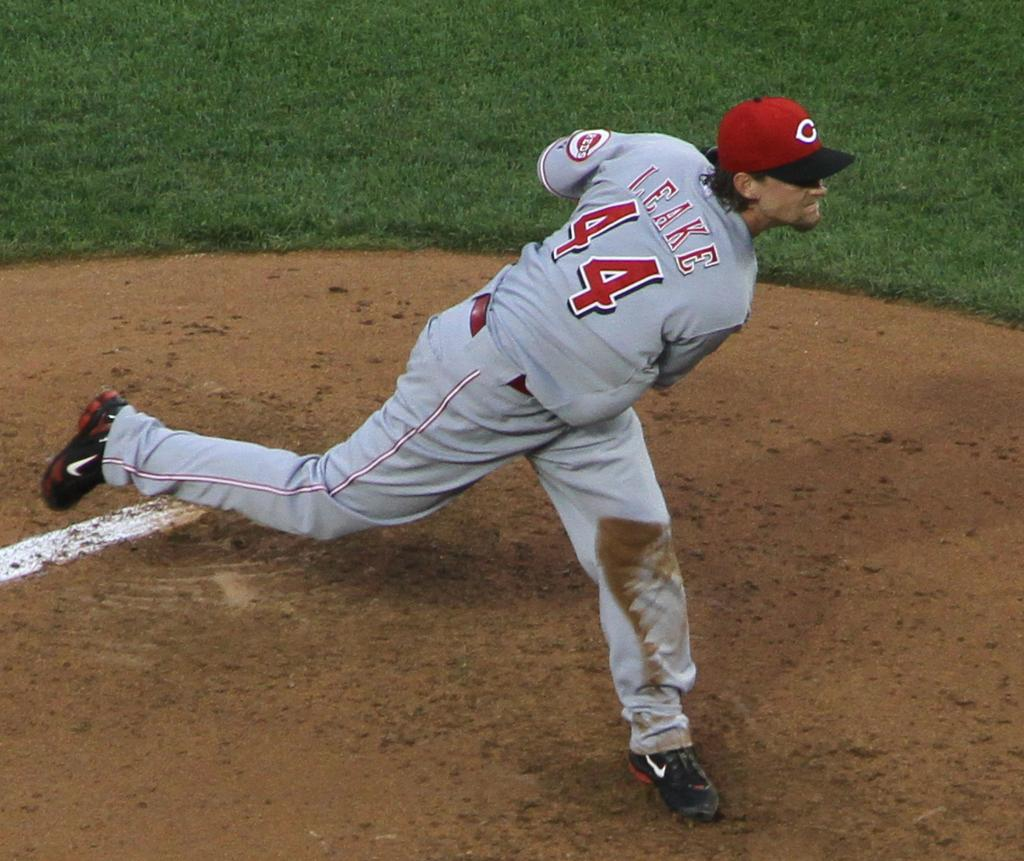<image>
Present a compact description of the photo's key features. Cincinnati Reds pitcher Mike Leake at the end of his wind up after releasing a pitch. 